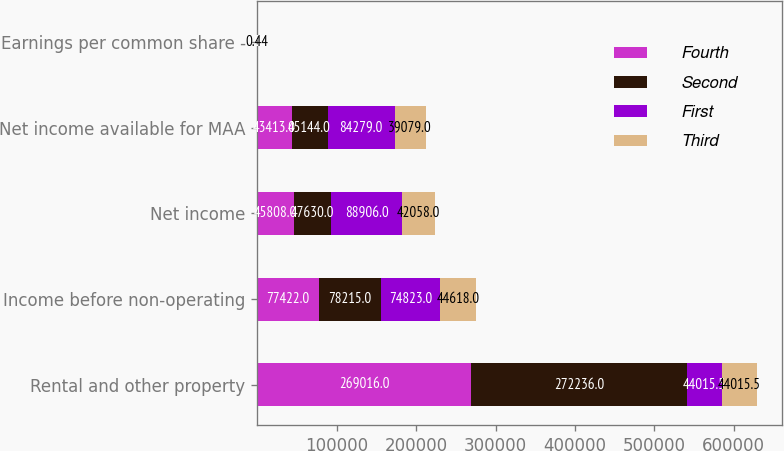<chart> <loc_0><loc_0><loc_500><loc_500><stacked_bar_chart><ecel><fcel>Rental and other property<fcel>Income before non-operating<fcel>Net income<fcel>Net income available for MAA<fcel>Earnings per common share -<nl><fcel>Fourth<fcel>269016<fcel>77422<fcel>45808<fcel>43413<fcel>0.58<nl><fcel>Second<fcel>272236<fcel>78215<fcel>47630<fcel>45144<fcel>0.6<nl><fcel>First<fcel>44015.5<fcel>74823<fcel>88906<fcel>84279<fcel>1.12<nl><fcel>Third<fcel>44015.5<fcel>44618<fcel>42058<fcel>39079<fcel>0.44<nl></chart> 